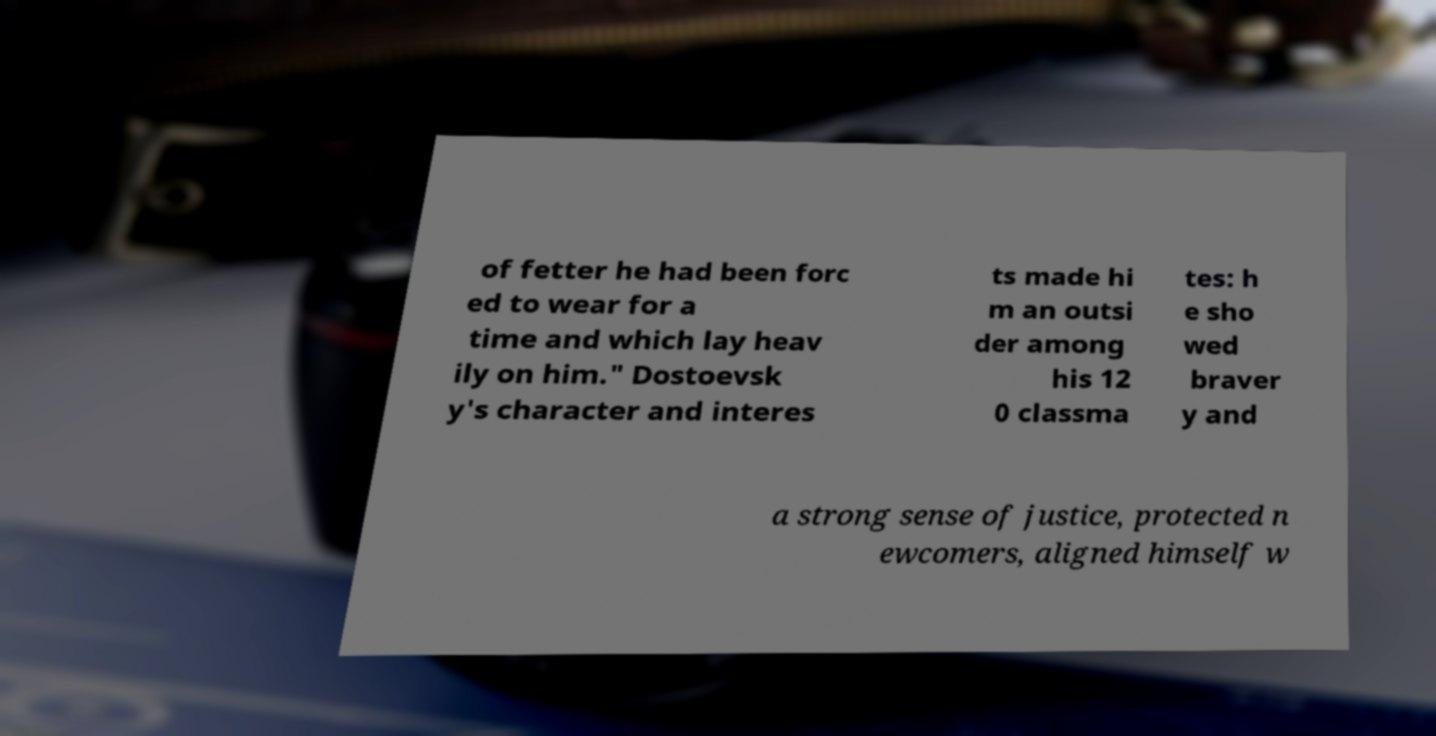For documentation purposes, I need the text within this image transcribed. Could you provide that? of fetter he had been forc ed to wear for a time and which lay heav ily on him." Dostoevsk y's character and interes ts made hi m an outsi der among his 12 0 classma tes: h e sho wed braver y and a strong sense of justice, protected n ewcomers, aligned himself w 